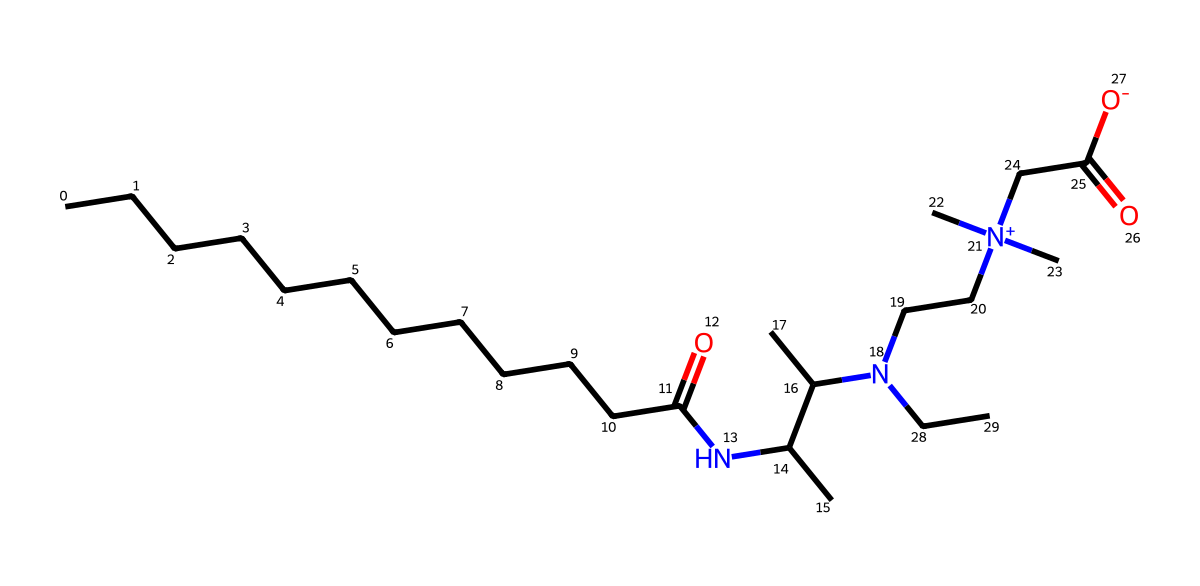What is the total number of carbon atoms in cocamidopropyl betaine? By analyzing the SMILES representation, we can count the occurrences of 'C', which represents carbon. The structure contains a total of 18 carbon atoms.
Answer: 18 How many amine (-NH) groups are present in the structure? In the given SMILES, the presence of 'N' indicates nitrogen, which is part of the amine functional group. Upon examining the structure, there are two nitrogen atoms, meaning there are two amine groups.
Answer: 2 What functional group is indicated by the 'C(=O)' part in the SMILES? The 'C(=O)' signifies a carbonyl group, which is a functional group with a carbon atom double-bonded to an oxygen atom. This structure indicates the presence of carboxyl or amide functionalities depending on the surrounding atoms.
Answer: carbonyl What type of surfactant is represented by cocamidopropyl betaine? Cocamidopropyl betaine has both hydrophilic and hydrophobic sections, indicating it is an amphoteric surfactant. Such surfactants can act as either cationic or anionic depending on the pH, thus this classification applies.
Answer: amphoteric How many oxygen atoms are present in the molecular structure? By inspecting the SMILES string, we can count the oxygen atoms represented by 'O'. There are three 'O' in the structure indicating a total of three oxygen atoms.
Answer: 3 What does the 'N+' in the chemical structure signify? The 'N+' refers to a positively charged nitrogen atom, which indicates this molecule has a quaternary ammonium ion. This is characteristic in surfactants such as betaines, contributing to its surfactant properties.
Answer: quaternary ammonium ion 